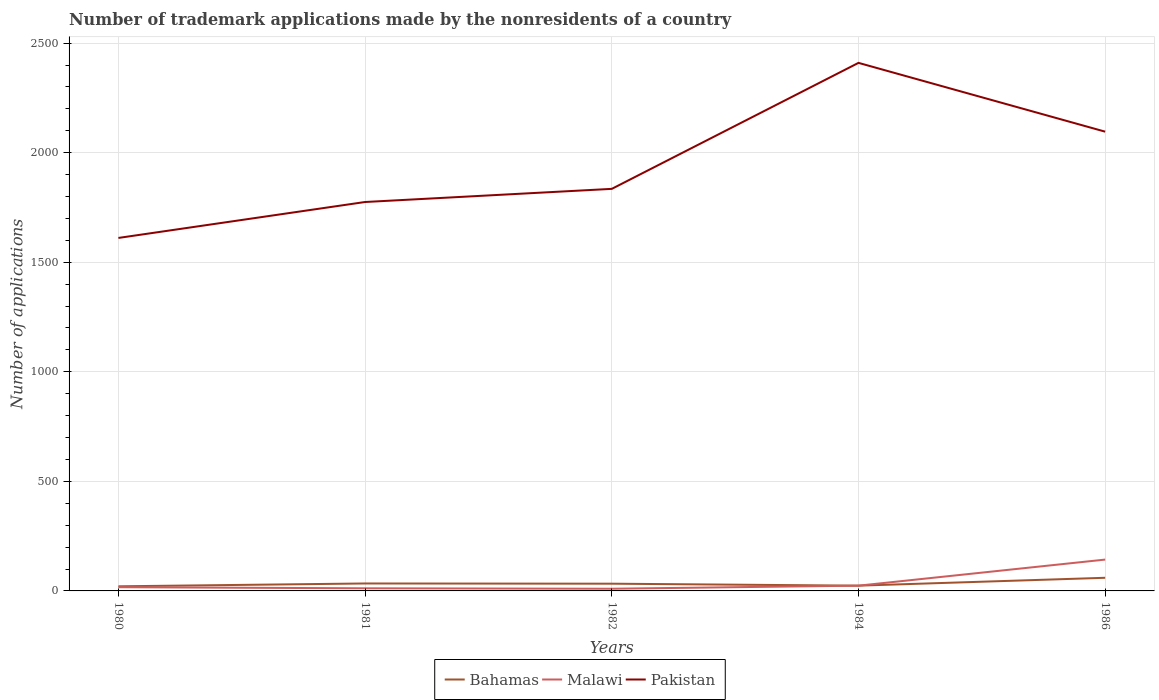How many different coloured lines are there?
Your answer should be compact. 3. Does the line corresponding to Bahamas intersect with the line corresponding to Pakistan?
Provide a short and direct response. No. Is the number of lines equal to the number of legend labels?
Your response must be concise. Yes. Across all years, what is the maximum number of trademark applications made by the nonresidents in Bahamas?
Provide a succinct answer. 21. What is the total number of trademark applications made by the nonresidents in Pakistan in the graph?
Ensure brevity in your answer.  314. What is the difference between the highest and the second highest number of trademark applications made by the nonresidents in Malawi?
Offer a very short reply. 133. Are the values on the major ticks of Y-axis written in scientific E-notation?
Offer a terse response. No. Does the graph contain any zero values?
Make the answer very short. No. Where does the legend appear in the graph?
Offer a terse response. Bottom center. How are the legend labels stacked?
Your answer should be very brief. Horizontal. What is the title of the graph?
Your answer should be very brief. Number of trademark applications made by the nonresidents of a country. Does "Middle income" appear as one of the legend labels in the graph?
Your answer should be very brief. No. What is the label or title of the X-axis?
Your answer should be very brief. Years. What is the label or title of the Y-axis?
Your answer should be very brief. Number of applications. What is the Number of applications of Bahamas in 1980?
Offer a very short reply. 21. What is the Number of applications in Malawi in 1980?
Give a very brief answer. 17. What is the Number of applications in Pakistan in 1980?
Give a very brief answer. 1611. What is the Number of applications in Pakistan in 1981?
Your answer should be very brief. 1775. What is the Number of applications of Malawi in 1982?
Provide a succinct answer. 10. What is the Number of applications of Pakistan in 1982?
Ensure brevity in your answer.  1835. What is the Number of applications of Malawi in 1984?
Provide a short and direct response. 24. What is the Number of applications of Pakistan in 1984?
Provide a short and direct response. 2410. What is the Number of applications of Bahamas in 1986?
Offer a terse response. 60. What is the Number of applications in Malawi in 1986?
Your response must be concise. 143. What is the Number of applications of Pakistan in 1986?
Give a very brief answer. 2096. Across all years, what is the maximum Number of applications of Bahamas?
Give a very brief answer. 60. Across all years, what is the maximum Number of applications of Malawi?
Give a very brief answer. 143. Across all years, what is the maximum Number of applications in Pakistan?
Provide a succinct answer. 2410. Across all years, what is the minimum Number of applications in Bahamas?
Give a very brief answer. 21. Across all years, what is the minimum Number of applications in Pakistan?
Your answer should be very brief. 1611. What is the total Number of applications in Bahamas in the graph?
Provide a succinct answer. 172. What is the total Number of applications of Malawi in the graph?
Ensure brevity in your answer.  206. What is the total Number of applications in Pakistan in the graph?
Make the answer very short. 9727. What is the difference between the Number of applications of Bahamas in 1980 and that in 1981?
Provide a succinct answer. -13. What is the difference between the Number of applications in Pakistan in 1980 and that in 1981?
Your answer should be compact. -164. What is the difference between the Number of applications of Bahamas in 1980 and that in 1982?
Keep it short and to the point. -12. What is the difference between the Number of applications in Pakistan in 1980 and that in 1982?
Give a very brief answer. -224. What is the difference between the Number of applications of Bahamas in 1980 and that in 1984?
Your response must be concise. -3. What is the difference between the Number of applications in Malawi in 1980 and that in 1984?
Your response must be concise. -7. What is the difference between the Number of applications of Pakistan in 1980 and that in 1984?
Offer a terse response. -799. What is the difference between the Number of applications of Bahamas in 1980 and that in 1986?
Offer a terse response. -39. What is the difference between the Number of applications of Malawi in 1980 and that in 1986?
Your answer should be very brief. -126. What is the difference between the Number of applications in Pakistan in 1980 and that in 1986?
Offer a terse response. -485. What is the difference between the Number of applications in Bahamas in 1981 and that in 1982?
Provide a short and direct response. 1. What is the difference between the Number of applications in Pakistan in 1981 and that in 1982?
Offer a very short reply. -60. What is the difference between the Number of applications in Malawi in 1981 and that in 1984?
Offer a terse response. -12. What is the difference between the Number of applications of Pakistan in 1981 and that in 1984?
Keep it short and to the point. -635. What is the difference between the Number of applications of Bahamas in 1981 and that in 1986?
Ensure brevity in your answer.  -26. What is the difference between the Number of applications in Malawi in 1981 and that in 1986?
Make the answer very short. -131. What is the difference between the Number of applications in Pakistan in 1981 and that in 1986?
Your answer should be compact. -321. What is the difference between the Number of applications in Malawi in 1982 and that in 1984?
Give a very brief answer. -14. What is the difference between the Number of applications in Pakistan in 1982 and that in 1984?
Provide a succinct answer. -575. What is the difference between the Number of applications in Bahamas in 1982 and that in 1986?
Provide a short and direct response. -27. What is the difference between the Number of applications in Malawi in 1982 and that in 1986?
Give a very brief answer. -133. What is the difference between the Number of applications in Pakistan in 1982 and that in 1986?
Your response must be concise. -261. What is the difference between the Number of applications in Bahamas in 1984 and that in 1986?
Make the answer very short. -36. What is the difference between the Number of applications of Malawi in 1984 and that in 1986?
Offer a very short reply. -119. What is the difference between the Number of applications of Pakistan in 1984 and that in 1986?
Make the answer very short. 314. What is the difference between the Number of applications in Bahamas in 1980 and the Number of applications in Malawi in 1981?
Provide a short and direct response. 9. What is the difference between the Number of applications in Bahamas in 1980 and the Number of applications in Pakistan in 1981?
Your answer should be very brief. -1754. What is the difference between the Number of applications of Malawi in 1980 and the Number of applications of Pakistan in 1981?
Provide a succinct answer. -1758. What is the difference between the Number of applications of Bahamas in 1980 and the Number of applications of Pakistan in 1982?
Provide a succinct answer. -1814. What is the difference between the Number of applications of Malawi in 1980 and the Number of applications of Pakistan in 1982?
Offer a terse response. -1818. What is the difference between the Number of applications in Bahamas in 1980 and the Number of applications in Malawi in 1984?
Keep it short and to the point. -3. What is the difference between the Number of applications of Bahamas in 1980 and the Number of applications of Pakistan in 1984?
Provide a short and direct response. -2389. What is the difference between the Number of applications of Malawi in 1980 and the Number of applications of Pakistan in 1984?
Ensure brevity in your answer.  -2393. What is the difference between the Number of applications of Bahamas in 1980 and the Number of applications of Malawi in 1986?
Offer a terse response. -122. What is the difference between the Number of applications of Bahamas in 1980 and the Number of applications of Pakistan in 1986?
Your answer should be very brief. -2075. What is the difference between the Number of applications of Malawi in 1980 and the Number of applications of Pakistan in 1986?
Give a very brief answer. -2079. What is the difference between the Number of applications in Bahamas in 1981 and the Number of applications in Malawi in 1982?
Keep it short and to the point. 24. What is the difference between the Number of applications of Bahamas in 1981 and the Number of applications of Pakistan in 1982?
Your answer should be very brief. -1801. What is the difference between the Number of applications of Malawi in 1981 and the Number of applications of Pakistan in 1982?
Your answer should be very brief. -1823. What is the difference between the Number of applications in Bahamas in 1981 and the Number of applications in Pakistan in 1984?
Give a very brief answer. -2376. What is the difference between the Number of applications in Malawi in 1981 and the Number of applications in Pakistan in 1984?
Give a very brief answer. -2398. What is the difference between the Number of applications of Bahamas in 1981 and the Number of applications of Malawi in 1986?
Your response must be concise. -109. What is the difference between the Number of applications of Bahamas in 1981 and the Number of applications of Pakistan in 1986?
Keep it short and to the point. -2062. What is the difference between the Number of applications in Malawi in 1981 and the Number of applications in Pakistan in 1986?
Offer a very short reply. -2084. What is the difference between the Number of applications of Bahamas in 1982 and the Number of applications of Malawi in 1984?
Make the answer very short. 9. What is the difference between the Number of applications in Bahamas in 1982 and the Number of applications in Pakistan in 1984?
Keep it short and to the point. -2377. What is the difference between the Number of applications in Malawi in 1982 and the Number of applications in Pakistan in 1984?
Offer a terse response. -2400. What is the difference between the Number of applications in Bahamas in 1982 and the Number of applications in Malawi in 1986?
Offer a very short reply. -110. What is the difference between the Number of applications of Bahamas in 1982 and the Number of applications of Pakistan in 1986?
Offer a very short reply. -2063. What is the difference between the Number of applications in Malawi in 1982 and the Number of applications in Pakistan in 1986?
Your answer should be compact. -2086. What is the difference between the Number of applications of Bahamas in 1984 and the Number of applications of Malawi in 1986?
Your answer should be compact. -119. What is the difference between the Number of applications in Bahamas in 1984 and the Number of applications in Pakistan in 1986?
Make the answer very short. -2072. What is the difference between the Number of applications in Malawi in 1984 and the Number of applications in Pakistan in 1986?
Your response must be concise. -2072. What is the average Number of applications in Bahamas per year?
Provide a succinct answer. 34.4. What is the average Number of applications in Malawi per year?
Offer a terse response. 41.2. What is the average Number of applications of Pakistan per year?
Ensure brevity in your answer.  1945.4. In the year 1980, what is the difference between the Number of applications in Bahamas and Number of applications in Pakistan?
Provide a succinct answer. -1590. In the year 1980, what is the difference between the Number of applications in Malawi and Number of applications in Pakistan?
Make the answer very short. -1594. In the year 1981, what is the difference between the Number of applications of Bahamas and Number of applications of Pakistan?
Your answer should be very brief. -1741. In the year 1981, what is the difference between the Number of applications of Malawi and Number of applications of Pakistan?
Provide a short and direct response. -1763. In the year 1982, what is the difference between the Number of applications of Bahamas and Number of applications of Malawi?
Ensure brevity in your answer.  23. In the year 1982, what is the difference between the Number of applications in Bahamas and Number of applications in Pakistan?
Make the answer very short. -1802. In the year 1982, what is the difference between the Number of applications in Malawi and Number of applications in Pakistan?
Your response must be concise. -1825. In the year 1984, what is the difference between the Number of applications of Bahamas and Number of applications of Malawi?
Keep it short and to the point. 0. In the year 1984, what is the difference between the Number of applications of Bahamas and Number of applications of Pakistan?
Your answer should be compact. -2386. In the year 1984, what is the difference between the Number of applications of Malawi and Number of applications of Pakistan?
Your response must be concise. -2386. In the year 1986, what is the difference between the Number of applications in Bahamas and Number of applications in Malawi?
Provide a short and direct response. -83. In the year 1986, what is the difference between the Number of applications in Bahamas and Number of applications in Pakistan?
Ensure brevity in your answer.  -2036. In the year 1986, what is the difference between the Number of applications of Malawi and Number of applications of Pakistan?
Your answer should be very brief. -1953. What is the ratio of the Number of applications in Bahamas in 1980 to that in 1981?
Offer a very short reply. 0.62. What is the ratio of the Number of applications of Malawi in 1980 to that in 1981?
Your answer should be very brief. 1.42. What is the ratio of the Number of applications of Pakistan in 1980 to that in 1981?
Offer a terse response. 0.91. What is the ratio of the Number of applications of Bahamas in 1980 to that in 1982?
Ensure brevity in your answer.  0.64. What is the ratio of the Number of applications in Malawi in 1980 to that in 1982?
Your response must be concise. 1.7. What is the ratio of the Number of applications in Pakistan in 1980 to that in 1982?
Ensure brevity in your answer.  0.88. What is the ratio of the Number of applications of Malawi in 1980 to that in 1984?
Ensure brevity in your answer.  0.71. What is the ratio of the Number of applications in Pakistan in 1980 to that in 1984?
Your answer should be compact. 0.67. What is the ratio of the Number of applications in Bahamas in 1980 to that in 1986?
Ensure brevity in your answer.  0.35. What is the ratio of the Number of applications in Malawi in 1980 to that in 1986?
Offer a very short reply. 0.12. What is the ratio of the Number of applications in Pakistan in 1980 to that in 1986?
Provide a short and direct response. 0.77. What is the ratio of the Number of applications of Bahamas in 1981 to that in 1982?
Give a very brief answer. 1.03. What is the ratio of the Number of applications in Malawi in 1981 to that in 1982?
Your response must be concise. 1.2. What is the ratio of the Number of applications in Pakistan in 1981 to that in 1982?
Provide a short and direct response. 0.97. What is the ratio of the Number of applications of Bahamas in 1981 to that in 1984?
Ensure brevity in your answer.  1.42. What is the ratio of the Number of applications in Malawi in 1981 to that in 1984?
Offer a very short reply. 0.5. What is the ratio of the Number of applications in Pakistan in 1981 to that in 1984?
Offer a very short reply. 0.74. What is the ratio of the Number of applications in Bahamas in 1981 to that in 1986?
Ensure brevity in your answer.  0.57. What is the ratio of the Number of applications of Malawi in 1981 to that in 1986?
Offer a terse response. 0.08. What is the ratio of the Number of applications of Pakistan in 1981 to that in 1986?
Offer a terse response. 0.85. What is the ratio of the Number of applications of Bahamas in 1982 to that in 1984?
Give a very brief answer. 1.38. What is the ratio of the Number of applications of Malawi in 1982 to that in 1984?
Provide a succinct answer. 0.42. What is the ratio of the Number of applications of Pakistan in 1982 to that in 1984?
Give a very brief answer. 0.76. What is the ratio of the Number of applications in Bahamas in 1982 to that in 1986?
Your answer should be compact. 0.55. What is the ratio of the Number of applications of Malawi in 1982 to that in 1986?
Make the answer very short. 0.07. What is the ratio of the Number of applications of Pakistan in 1982 to that in 1986?
Offer a terse response. 0.88. What is the ratio of the Number of applications of Malawi in 1984 to that in 1986?
Give a very brief answer. 0.17. What is the ratio of the Number of applications of Pakistan in 1984 to that in 1986?
Provide a succinct answer. 1.15. What is the difference between the highest and the second highest Number of applications of Bahamas?
Your answer should be very brief. 26. What is the difference between the highest and the second highest Number of applications of Malawi?
Your answer should be compact. 119. What is the difference between the highest and the second highest Number of applications in Pakistan?
Offer a terse response. 314. What is the difference between the highest and the lowest Number of applications of Malawi?
Offer a terse response. 133. What is the difference between the highest and the lowest Number of applications of Pakistan?
Offer a terse response. 799. 